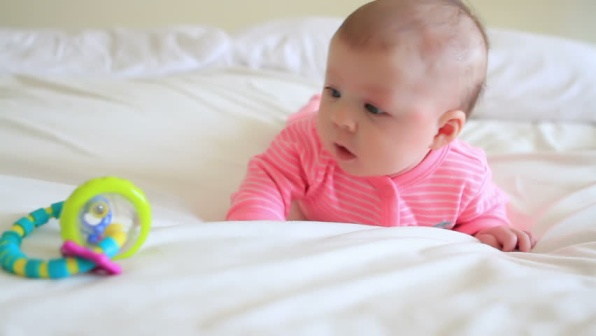What if the toy could talk? What would it say to the baby? "Hello there, little one! I'm your new friend, Rattle. Shake me, and I'll make fun sounds for you! Let's go on adventures together, and I'll always be by your side. Whenever you feel curious, just give me a shake, and we’ll explore the world of sounds and colors!" 